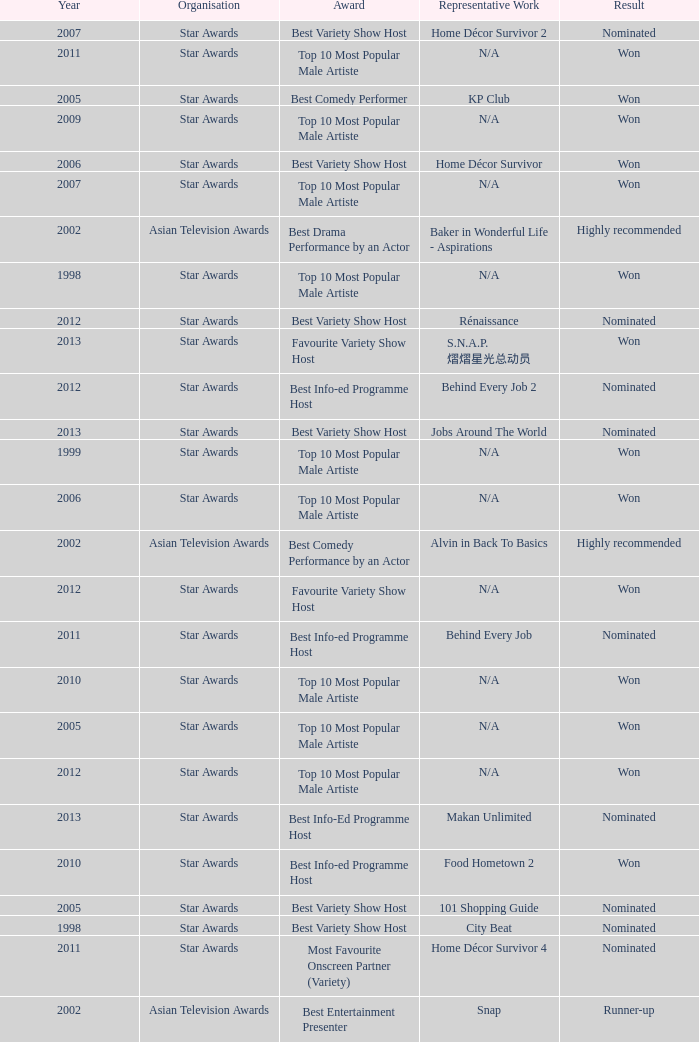What is the award for the Star Awards earlier than 2005 and the result is won? Top 10 Most Popular Male Artiste, Top 10 Most Popular Male Artiste. 